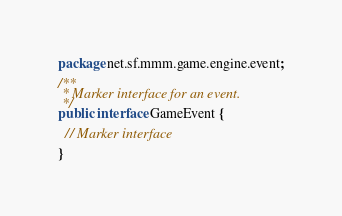<code> <loc_0><loc_0><loc_500><loc_500><_Java_>package net.sf.mmm.game.engine.event;

/**
 * Marker interface for an event.
 */
public interface GameEvent {

  // Marker interface

}
</code> 